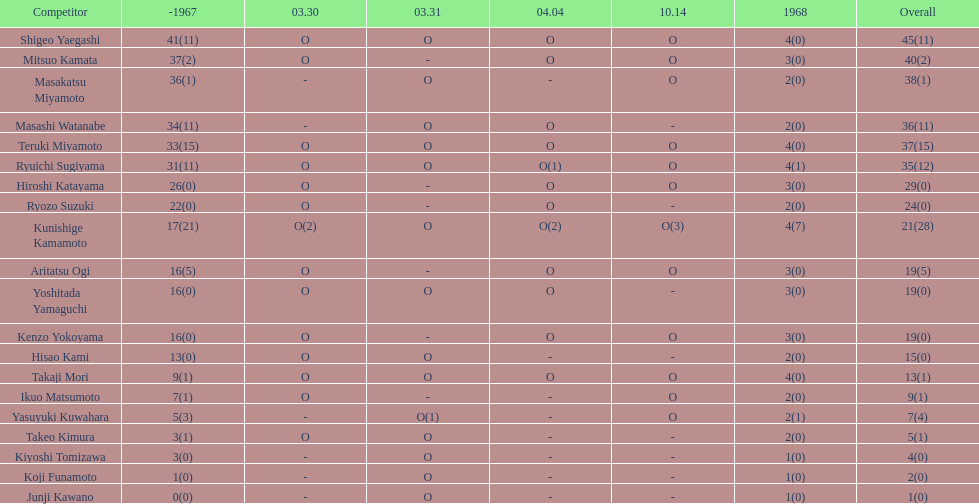During that year, what was the number of players who made an appearance? 20. 